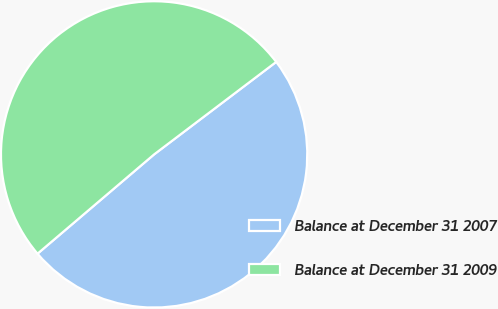<chart> <loc_0><loc_0><loc_500><loc_500><pie_chart><fcel>Balance at December 31 2007<fcel>Balance at December 31 2009<nl><fcel>49.09%<fcel>50.91%<nl></chart> 